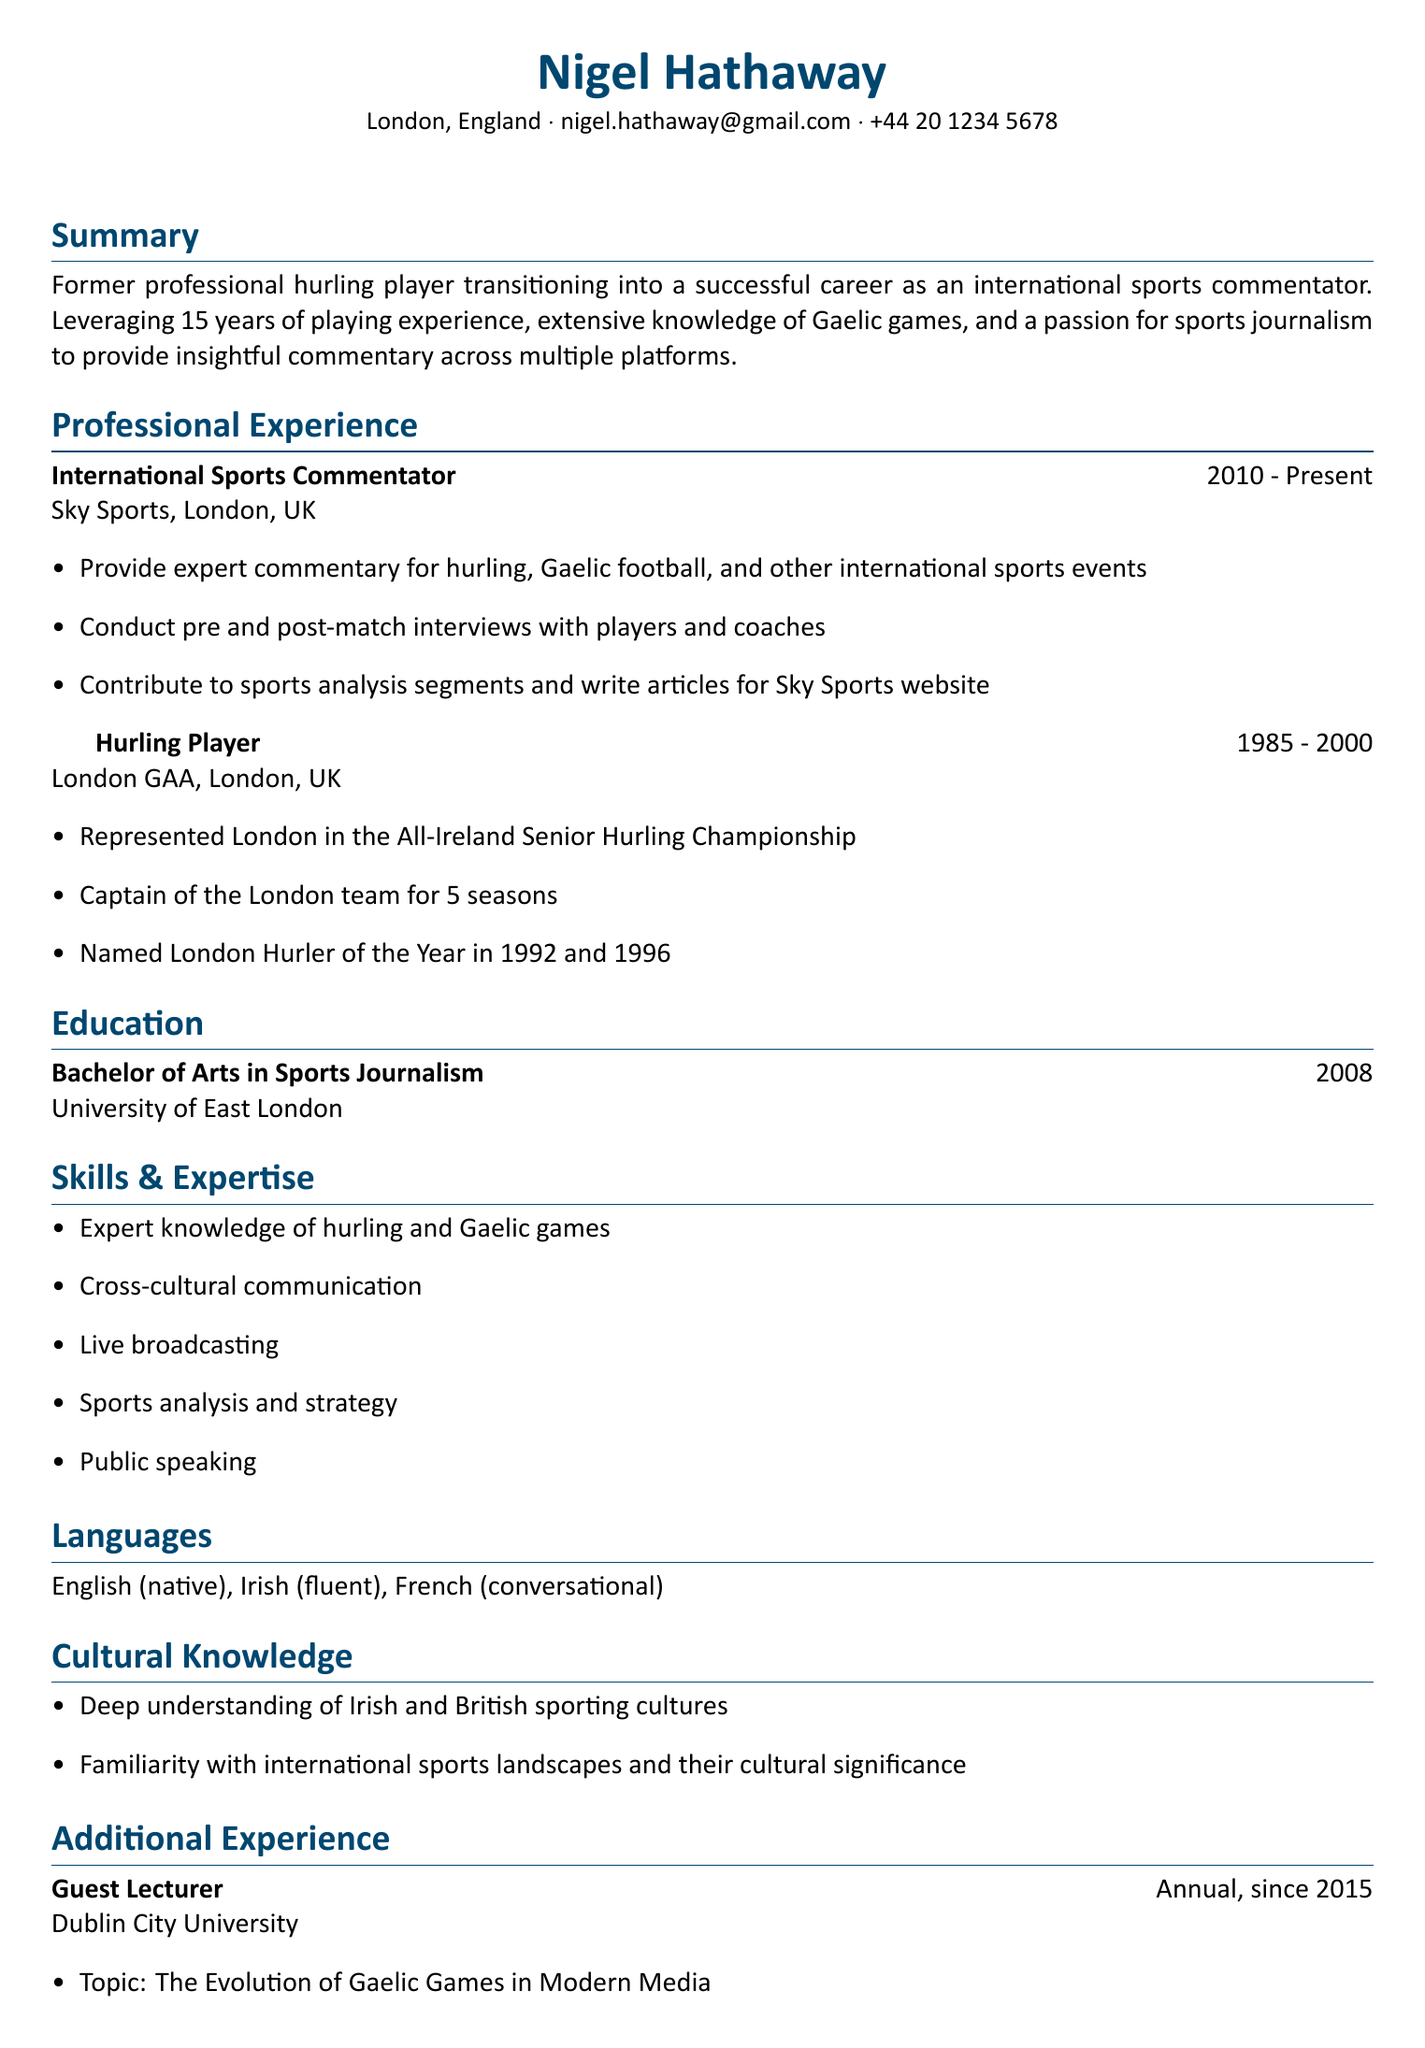What is Nigel Hathaway's age? The age of Nigel Hathaway is stated in the personal information section.
Answer: 62 Where does Nigel Hathaway currently work? The document indicates his employment in the professional experience section.
Answer: Sky Sports What position did Nigel hold in the London GAA team? This information can be found in the achievements of his professional experience as a Hurling Player.
Answer: Captain In which year did Nigel graduate from university? The graduation year is specified in the education section of the resume.
Answer: 2008 How many languages does Nigel speak? The number of languages is detailed in the languages section of the resume.
Answer: Three What is one of Nigel's responsibilities as an International Sports Commentator? This information can be found under the responsibilities listed for his current position.
Answer: Provide expert commentary What topic does Nigel lecture on at Dublin City University? This information is found in the additional experience section of the resume.
Answer: The Evolution of Gaelic Games in Modern Media What years did Nigel play for London GAA? The duration of his playing career is provided in the professional experience section.
Answer: 1985 - 2000 What notable achievements did Nigel earn while playing hurling? Achievements are listed in the professional experience section under Hurling Player.
Answer: London Hurler of the Year in 1992 and 1996 